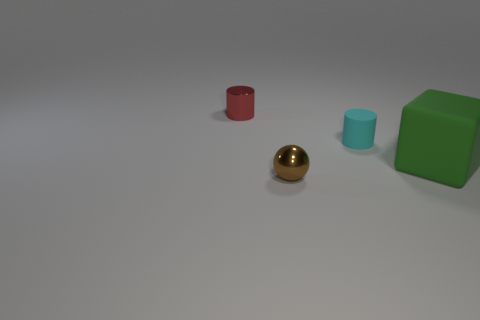Is the number of tiny cyan rubber things in front of the small red thing less than the number of cyan cylinders?
Your answer should be very brief. No. There is a thing behind the tiny cyan cylinder; what material is it?
Your answer should be very brief. Metal. What number of other things are there of the same size as the block?
Keep it short and to the point. 0. There is a metal cylinder; is its size the same as the rubber thing right of the cyan rubber cylinder?
Provide a short and direct response. No. There is a green matte thing that is behind the small metal object that is to the right of the small thing behind the cyan thing; what is its shape?
Keep it short and to the point. Cube. Are there fewer big matte blocks than tiny cylinders?
Keep it short and to the point. Yes. There is a small red cylinder; are there any red metallic cylinders behind it?
Ensure brevity in your answer.  No. What shape is the small object that is in front of the red shiny thing and behind the large thing?
Offer a very short reply. Cylinder. Are there any matte things that have the same shape as the small red metal thing?
Give a very brief answer. Yes. There is a metallic object behind the big object; does it have the same size as the object right of the cyan cylinder?
Provide a succinct answer. No. 